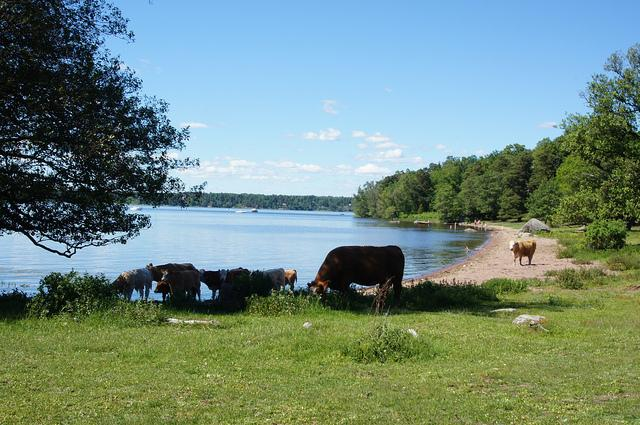How many animal species are shown NOT including the people on shore? Please explain your reasoning. one. Cows are the only animals in this photo 